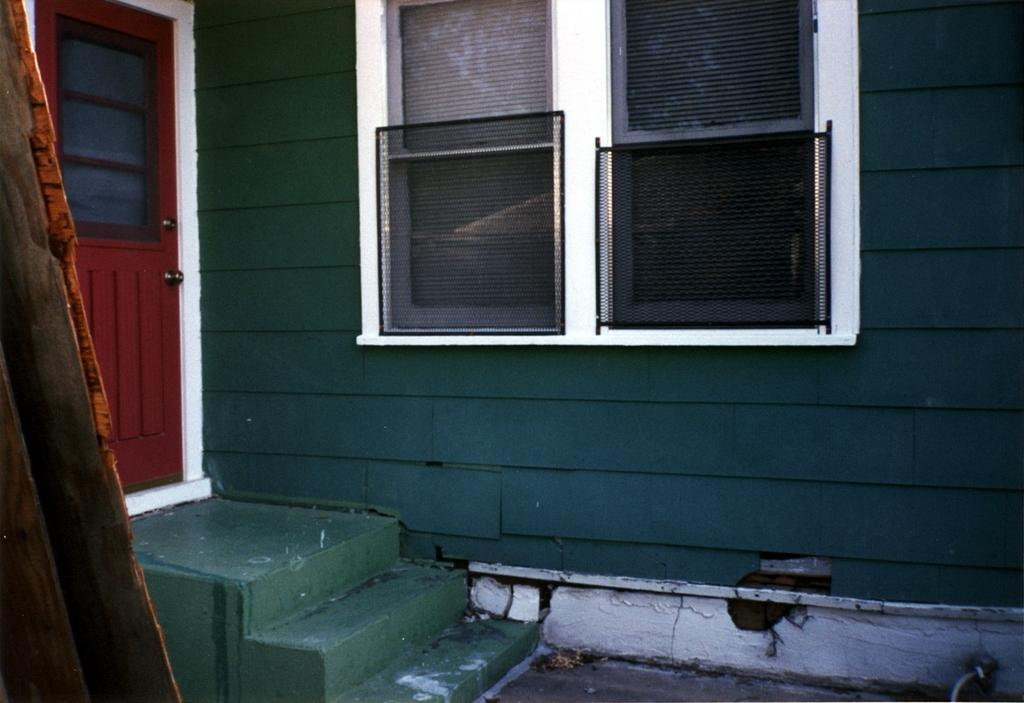What can be seen on the left side of the image? There is a staircase on the left side of the image. What is another architectural feature present in the image? There is a door in the image. What type of material is used for the wooden object in the image? The wooden object in the image is made of wood. What is located in the middle of the image? There are windows and a wall in the middle of the image. What is visible at the bottom of the image? There is a floor visible at the bottom of the image. Is there a slope visible in the image? No, there is no slope present in the image. Can you see a river in the image? No, there is no river present in the image. 